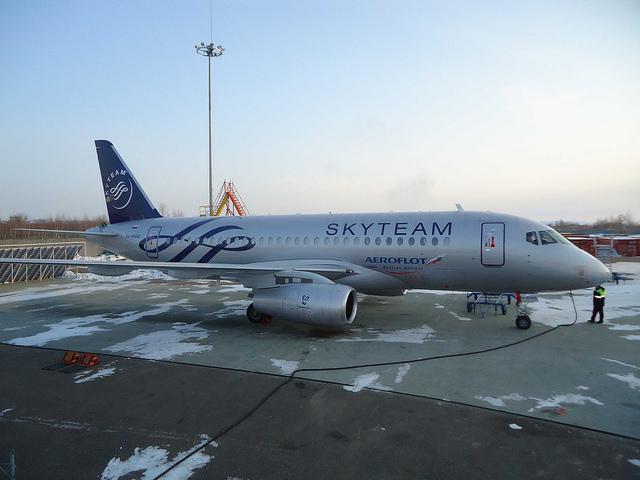How many cars are in between the buses?
Give a very brief answer. 0. 